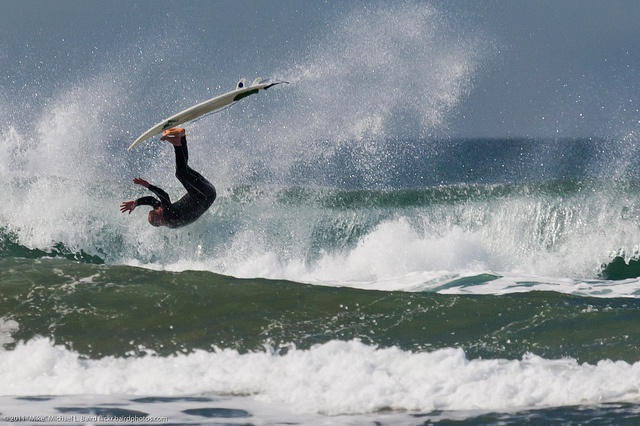Describe the objects in this image and their specific colors. I can see people in gray, black, darkgray, and maroon tones and surfboard in gray, darkgray, black, and lightgray tones in this image. 